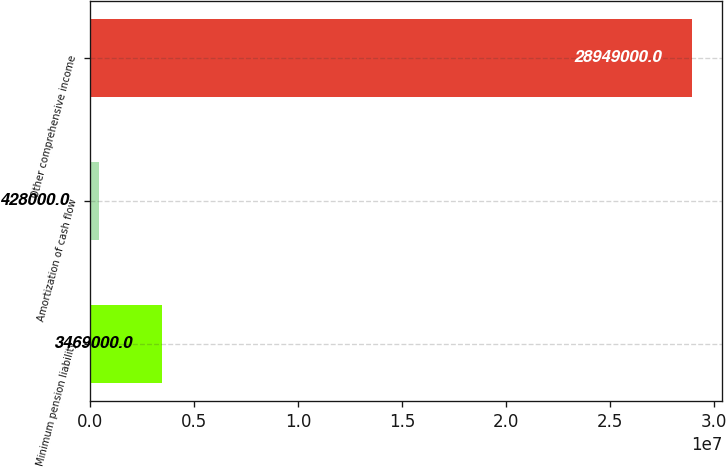<chart> <loc_0><loc_0><loc_500><loc_500><bar_chart><fcel>Minimum pension liability<fcel>Amortization of cash flow<fcel>Other comprehensive income<nl><fcel>3.469e+06<fcel>428000<fcel>2.8949e+07<nl></chart> 